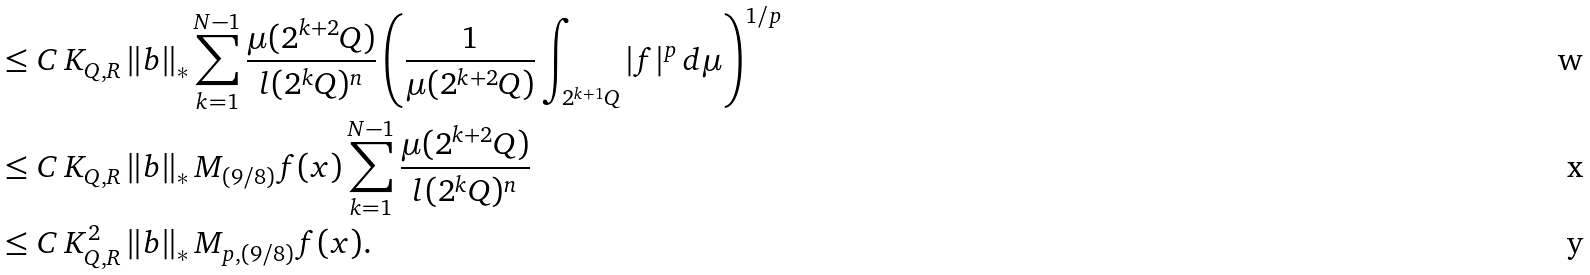Convert formula to latex. <formula><loc_0><loc_0><loc_500><loc_500>& \leq C \, K _ { Q , R } \, \| b \| _ { * } \sum _ { k = 1 } ^ { N - 1 } \frac { \mu ( 2 ^ { k + 2 } Q ) } { l ( 2 ^ { k } Q ) ^ { n } } \left ( \frac { 1 } { \mu ( 2 ^ { k + 2 } Q ) } \int _ { 2 ^ { k + 1 } Q } | f | ^ { p } \, d \mu \right ) ^ { 1 / p } \\ & \leq C \, K _ { Q , R } \, \| b \| _ { * } \, M _ { ( 9 / 8 ) } f ( x ) \sum _ { k = 1 } ^ { N - 1 } \frac { \mu ( 2 ^ { k + 2 } Q ) } { l ( 2 ^ { k } Q ) ^ { n } } \\ & \leq C \, K _ { Q , R } ^ { 2 } \, \| b \| _ { * } \, M _ { p , ( 9 / 8 ) } f ( x ) .</formula> 